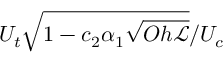Convert formula to latex. <formula><loc_0><loc_0><loc_500><loc_500>U _ { t } \sqrt { 1 - c _ { 2 } \alpha _ { 1 } \sqrt { O h { \ m a t h s c r { L } } } } / U _ { c }</formula> 